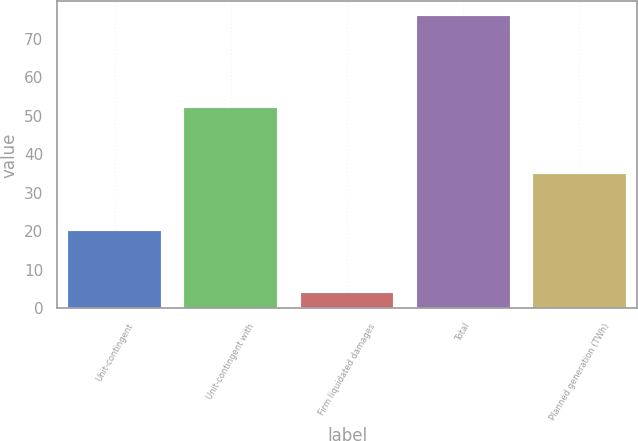Convert chart. <chart><loc_0><loc_0><loc_500><loc_500><bar_chart><fcel>Unit-contingent<fcel>Unit-contingent with<fcel>Firm liquidated damages<fcel>Total<fcel>Planned generation (TWh)<nl><fcel>20<fcel>52<fcel>4<fcel>76<fcel>35<nl></chart> 